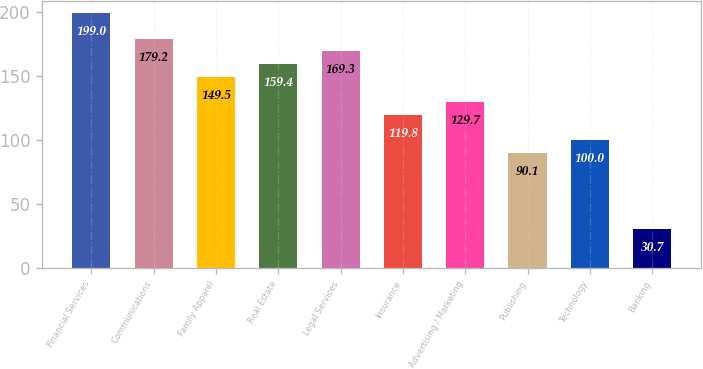Convert chart to OTSL. <chart><loc_0><loc_0><loc_500><loc_500><bar_chart><fcel>Financial Services<fcel>Communications<fcel>Family Apparel<fcel>Real Estate<fcel>Legal Services<fcel>Insurance<fcel>Advertising / Marketing<fcel>Publishing<fcel>Technology<fcel>Banking<nl><fcel>199<fcel>179.2<fcel>149.5<fcel>159.4<fcel>169.3<fcel>119.8<fcel>129.7<fcel>90.1<fcel>100<fcel>30.7<nl></chart> 